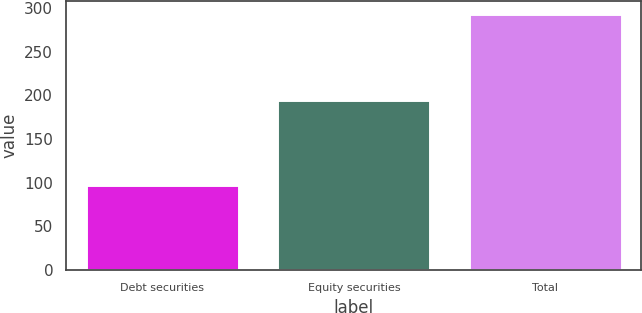Convert chart to OTSL. <chart><loc_0><loc_0><loc_500><loc_500><bar_chart><fcel>Debt securities<fcel>Equity securities<fcel>Total<nl><fcel>97<fcel>195<fcel>293<nl></chart> 